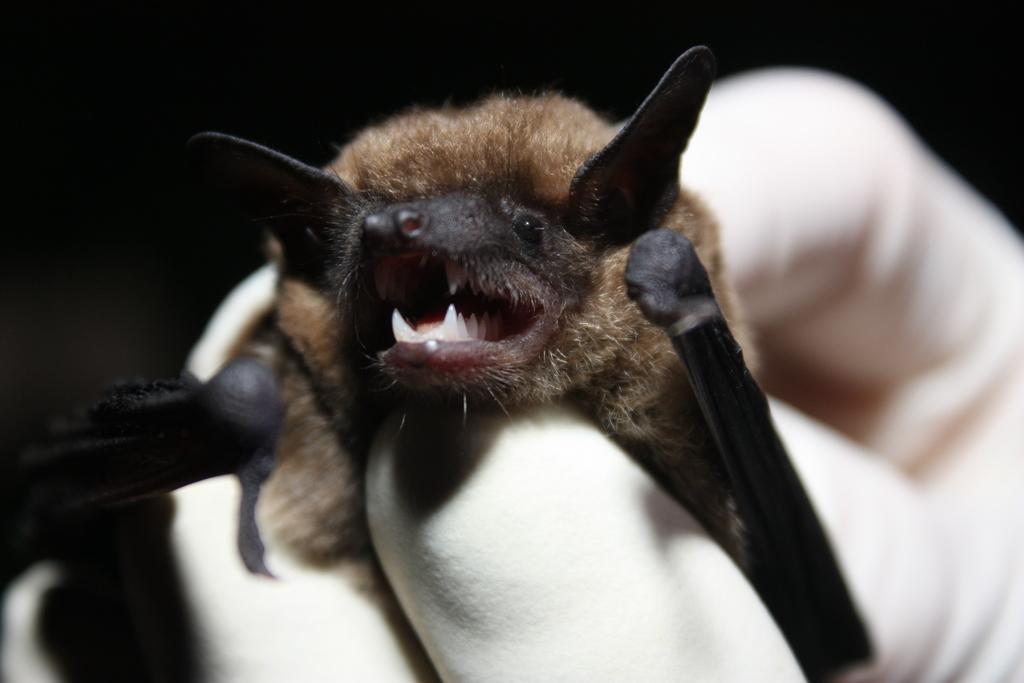In one or two sentences, can you explain what this image depicts? Here we can see a bat in the hands of a person. In the background the image is dark. 